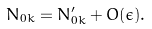<formula> <loc_0><loc_0><loc_500><loc_500>N _ { 0 k } = N _ { 0 k } ^ { \prime } + O ( \epsilon ) .</formula> 